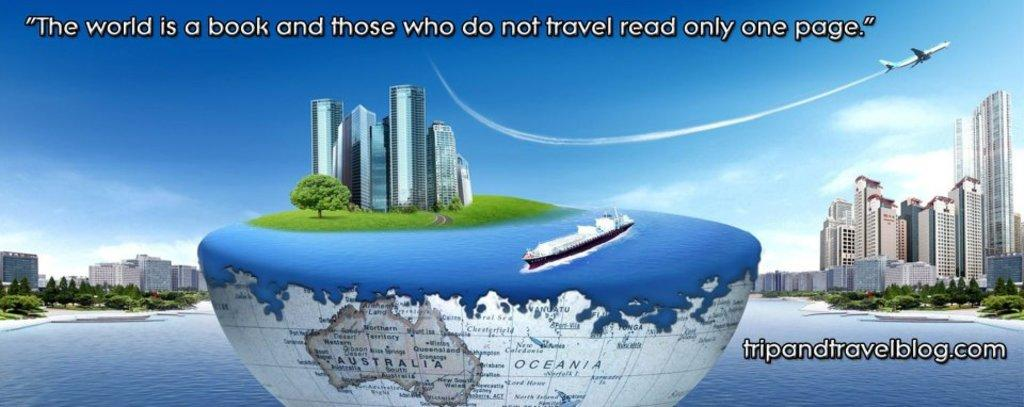<image>
Relay a brief, clear account of the picture shown. The boat floats on a globe cut in half with only the Australian continent still visible on the map. 